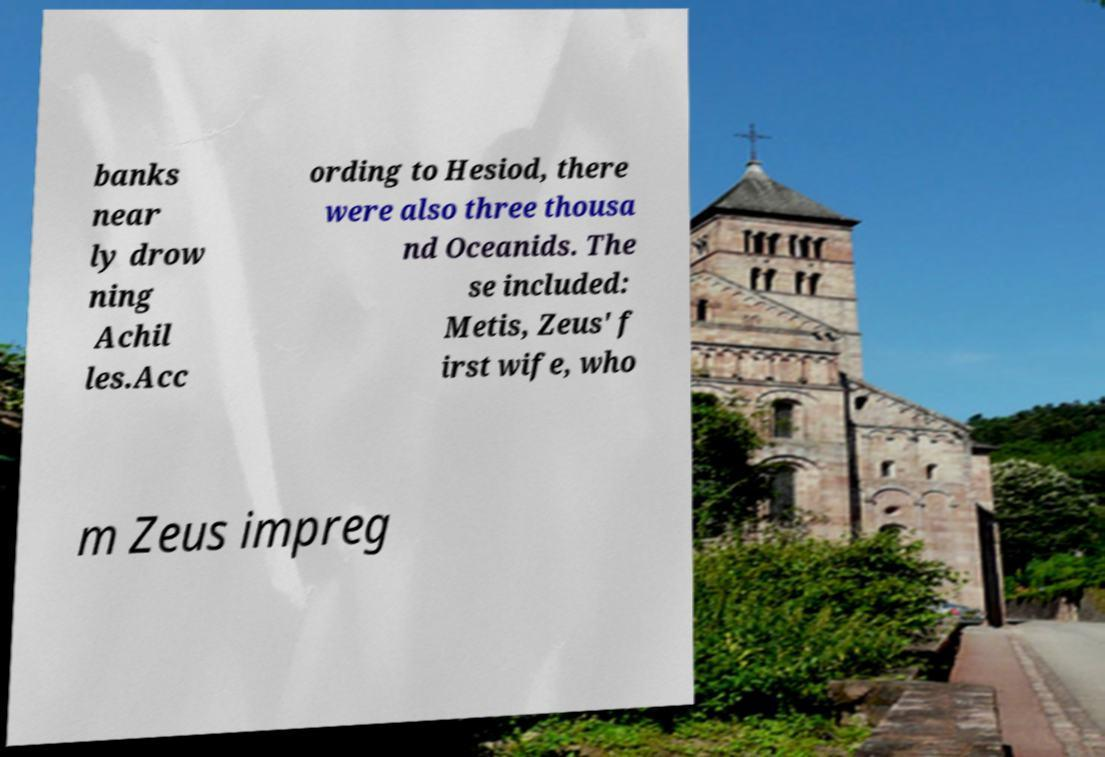I need the written content from this picture converted into text. Can you do that? banks near ly drow ning Achil les.Acc ording to Hesiod, there were also three thousa nd Oceanids. The se included: Metis, Zeus' f irst wife, who m Zeus impreg 